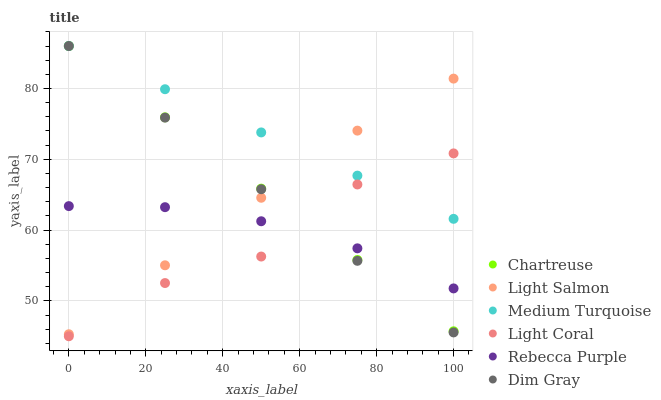Does Light Coral have the minimum area under the curve?
Answer yes or no. Yes. Does Medium Turquoise have the maximum area under the curve?
Answer yes or no. Yes. Does Dim Gray have the minimum area under the curve?
Answer yes or no. No. Does Dim Gray have the maximum area under the curve?
Answer yes or no. No. Is Dim Gray the smoothest?
Answer yes or no. Yes. Is Light Coral the roughest?
Answer yes or no. Yes. Is Light Coral the smoothest?
Answer yes or no. No. Is Dim Gray the roughest?
Answer yes or no. No. Does Light Coral have the lowest value?
Answer yes or no. Yes. Does Dim Gray have the lowest value?
Answer yes or no. No. Does Medium Turquoise have the highest value?
Answer yes or no. Yes. Does Light Coral have the highest value?
Answer yes or no. No. Is Light Coral less than Light Salmon?
Answer yes or no. Yes. Is Medium Turquoise greater than Rebecca Purple?
Answer yes or no. Yes. Does Dim Gray intersect Light Coral?
Answer yes or no. Yes. Is Dim Gray less than Light Coral?
Answer yes or no. No. Is Dim Gray greater than Light Coral?
Answer yes or no. No. Does Light Coral intersect Light Salmon?
Answer yes or no. No. 